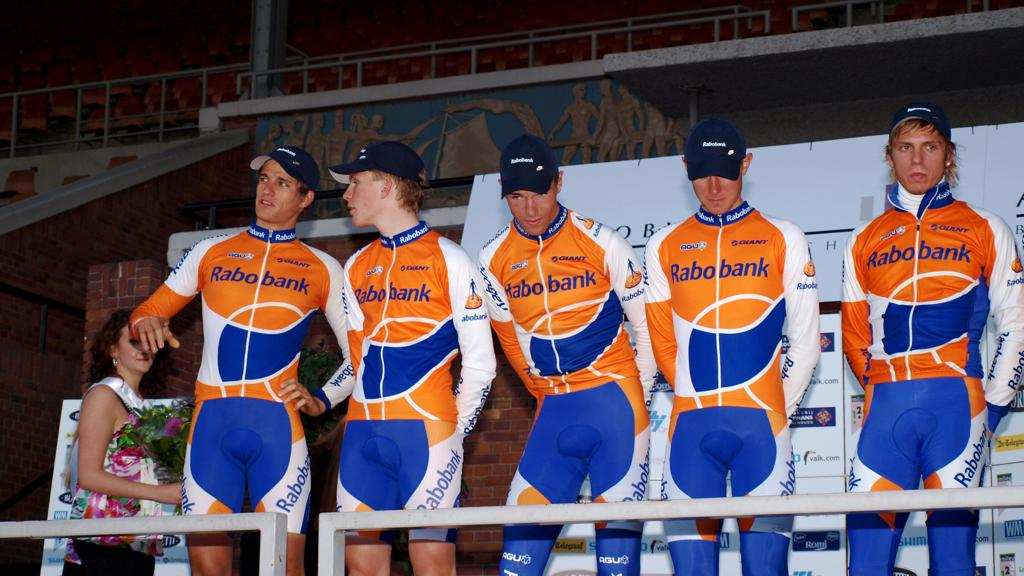<image>
Relay a brief, clear account of the picture shown. Five men wearing matching suits with the robo bank logo on their chests. 